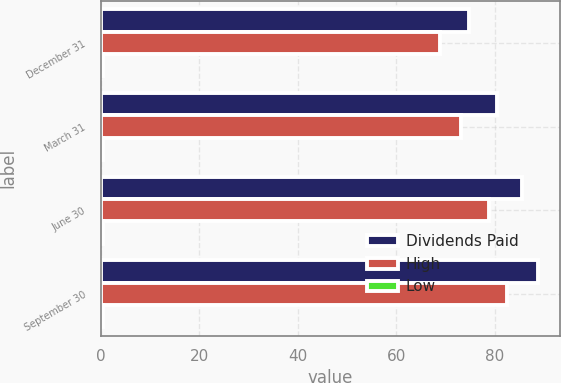Convert chart to OTSL. <chart><loc_0><loc_0><loc_500><loc_500><stacked_bar_chart><ecel><fcel>December 31<fcel>March 31<fcel>June 30<fcel>September 30<nl><fcel>Dividends Paid<fcel>74.73<fcel>80.4<fcel>85.54<fcel>88.69<nl><fcel>High<fcel>68.96<fcel>73.21<fcel>78.9<fcel>82.42<nl><fcel>Low<fcel>0.45<fcel>0.45<fcel>0.45<fcel>0.45<nl></chart> 